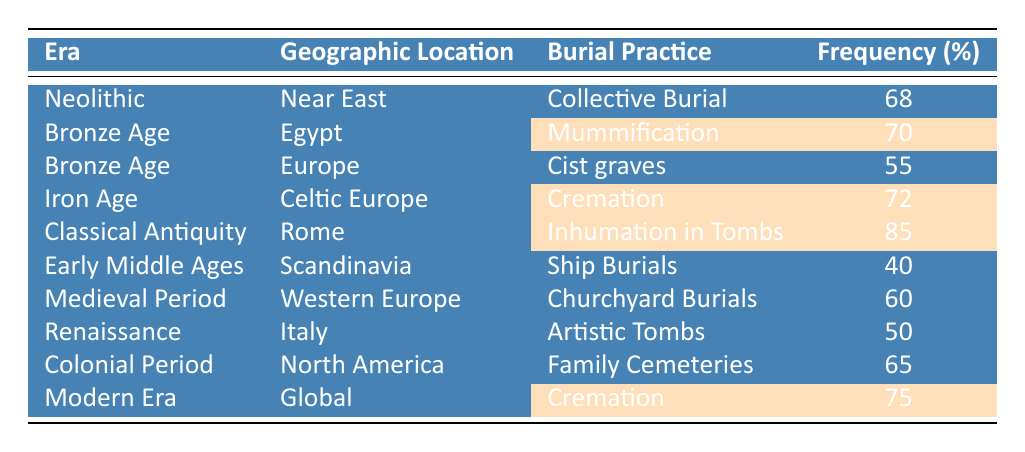What burial practice has the highest frequency in Classical Antiquity? The table indicates that the burial practice with the highest frequency in Classical Antiquity is Inhumation in Tombs, which has a frequency of 85%.
Answer: Inhumation in Tombs Which era has the lowest frequency of burial practices? According to the table, the Early Middle Ages has the lowest frequency at 40% for Ship Burials.
Answer: Early Middle Ages What is the average frequency of burial practices in the Bronze Age? The frequencies for Bronze Age are 70 (Egypt) and 55 (Europe). Adding these gives 125, divided by 2 for the average: 125/2 = 62.5.
Answer: 62.5 Is cremation used in both the Iron Age and the Modern Era? The table shows that cremation is indicated for both the Iron Age (72%) and the Modern Era (75%). Therefore, the answer is yes.
Answer: Yes What is the difference in frequency between Mummification in Egypt and Churchyard Burials in Western Europe? Mummification in Egypt has a frequency of 70%, while Churchyard Burials has a frequency of 60%. The difference is 70 - 60 = 10.
Answer: 10 How many burial practices have a frequency greater than 65%? The practices with frequencies greater than 65% are Mummification (70%), Cremation (72%), Inhumation in Tombs (85%), and Cremation in the Modern Era (75%). This totals 4 practices.
Answer: 4 Which geographic location has a recognized burial practice with a non-highlighted frequency? The table shows that cist graves in Europe (55%) and Ship Burials in Scandinavia (40%) are examples of burial practices with non-highlighted frequencies.
Answer: Europe (Cist graves) and Scandinavia (Ship Burials) Calculate the sum of the frequencies for Funeral practices in Europe. The table provides two practices for Europe: Cist graves (55%) and Churchyard Burials (60% in Western Europe). Summing these frequencies gives 55 + 60 = 115.
Answer: 115 Which era is associated with Family Cemeteries? According to the table, Family Cemeteries is associated with the Colonial Period, which is specified in the data.
Answer: Colonial Period Is the frequency of Artistic Tombs in Italy greater than that of Ship Burials in Scandinavia? The frequency of Artistic Tombs in Italy is 50%, while Ship Burials in Scandinavia is 40%. Since 50% is greater than 40%, the answer is yes.
Answer: Yes 